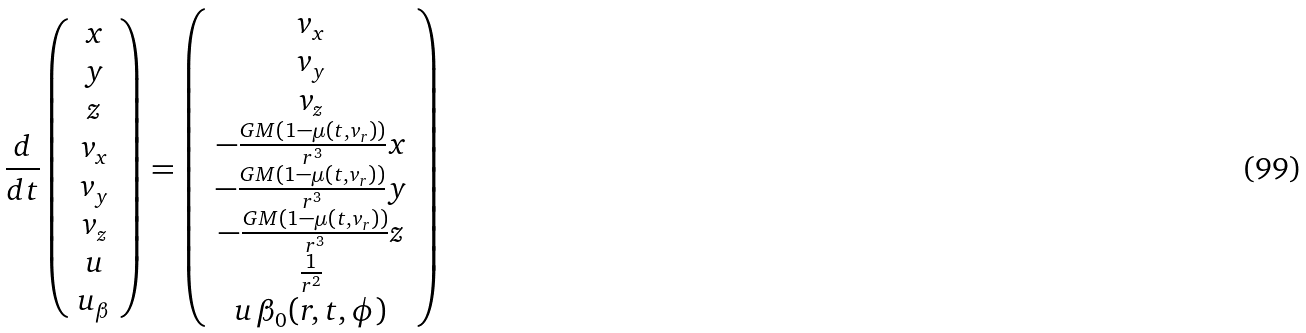Convert formula to latex. <formula><loc_0><loc_0><loc_500><loc_500>\frac { d } { d t } \left ( \begin{array} { c } x \\ y \\ z \\ v _ { x } \\ v _ { y } \\ v _ { z } \\ u \\ u _ { \beta } \end{array} \right ) = \left ( \begin{array} { c } v _ { x } \\ v _ { y } \\ v _ { z } \\ - \frac { G M \left ( 1 - \mu \left ( t , v _ { r } \right ) \right ) } { r ^ { 3 } } x \\ - \frac { G M \left ( 1 - \mu \left ( t , v _ { r } \right ) \right ) } { r ^ { 3 } } y \\ - \frac { G M \left ( 1 - \mu \left ( t , v _ { r } \right ) \right ) } { r ^ { 3 } } z \\ \frac { 1 } { r ^ { 2 } } \\ u \, \beta _ { 0 } ( r , t , \phi ) \end{array} \right )</formula> 